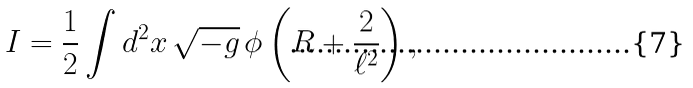<formula> <loc_0><loc_0><loc_500><loc_500>I = \frac { 1 } { 2 } \int d ^ { 2 } x \, \sqrt { - g } \, \phi \left ( R + \frac { 2 } { \ell ^ { 2 } } \right ) ,</formula> 